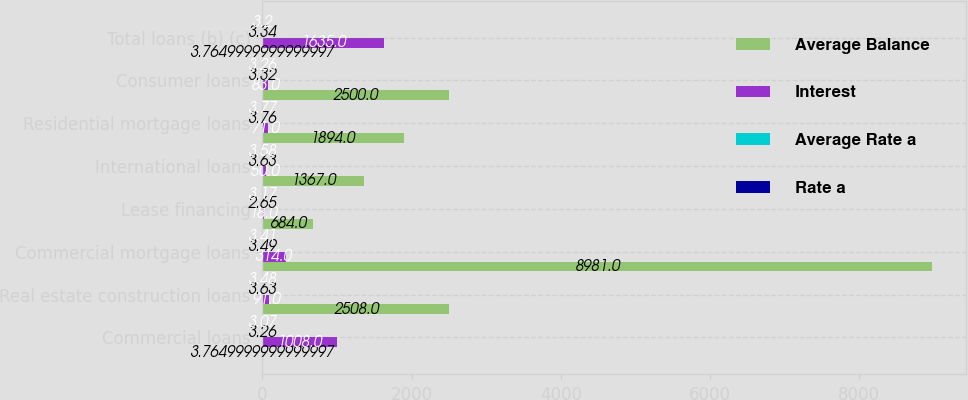Convert chart. <chart><loc_0><loc_0><loc_500><loc_500><stacked_bar_chart><ecel><fcel>Commercial loans<fcel>Real estate construction loans<fcel>Commercial mortgage loans<fcel>Lease financing<fcel>International loans<fcel>Residential mortgage loans<fcel>Consumer loans<fcel>Total loans (b) (c)<nl><fcel>Average Balance<fcel>3.765<fcel>2508<fcel>8981<fcel>684<fcel>1367<fcel>1894<fcel>2500<fcel>3.765<nl><fcel>Interest<fcel>1008<fcel>91<fcel>314<fcel>18<fcel>50<fcel>71<fcel>83<fcel>1635<nl><fcel>Average Rate a<fcel>3.26<fcel>3.63<fcel>3.49<fcel>2.65<fcel>3.63<fcel>3.76<fcel>3.32<fcel>3.34<nl><fcel>Rate a<fcel>3.07<fcel>3.48<fcel>3.41<fcel>3.17<fcel>3.58<fcel>3.77<fcel>3.26<fcel>3.2<nl></chart> 